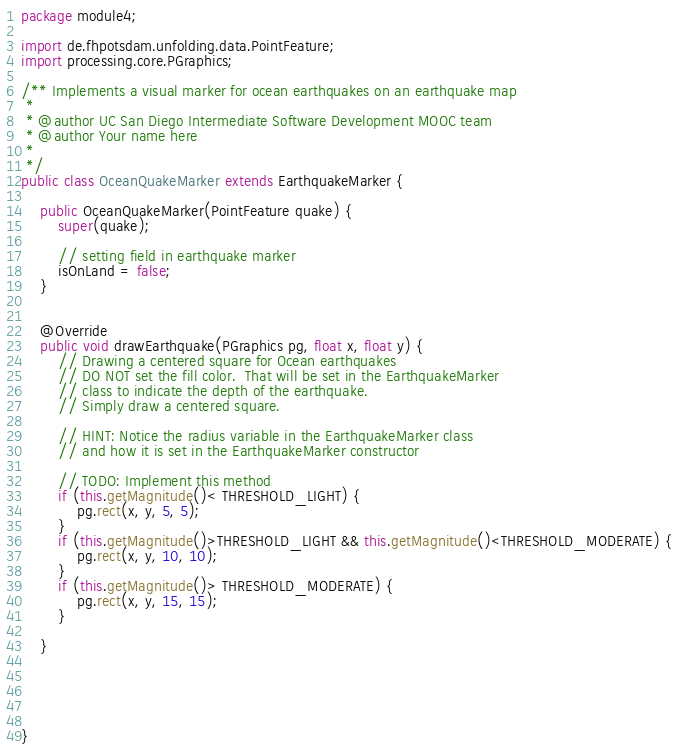<code> <loc_0><loc_0><loc_500><loc_500><_Java_>package module4;

import de.fhpotsdam.unfolding.data.PointFeature;
import processing.core.PGraphics;

/** Implements a visual marker for ocean earthquakes on an earthquake map
 * 
 * @author UC San Diego Intermediate Software Development MOOC team
 * @author Your name here
 *
 */
public class OceanQuakeMarker extends EarthquakeMarker {
	
	public OceanQuakeMarker(PointFeature quake) {
		super(quake);
		
		// setting field in earthquake marker
		isOnLand = false;
	}
	

	@Override
	public void drawEarthquake(PGraphics pg, float x, float y) {
		// Drawing a centered square for Ocean earthquakes
		// DO NOT set the fill color.  That will be set in the EarthquakeMarker
		// class to indicate the depth of the earthquake.
		// Simply draw a centered square.
		
		// HINT: Notice the radius variable in the EarthquakeMarker class
		// and how it is set in the EarthquakeMarker constructor
		
		// TODO: Implement this method
		if (this.getMagnitude()< THRESHOLD_LIGHT) {
			pg.rect(x, y, 5, 5);
		}
		if (this.getMagnitude()>THRESHOLD_LIGHT && this.getMagnitude()<THRESHOLD_MODERATE) {
			pg.rect(x, y, 10, 10);
		}
		if (this.getMagnitude()> THRESHOLD_MODERATE) {
			pg.rect(x, y, 15, 15);
		}
		
	}
	


	

}
</code> 